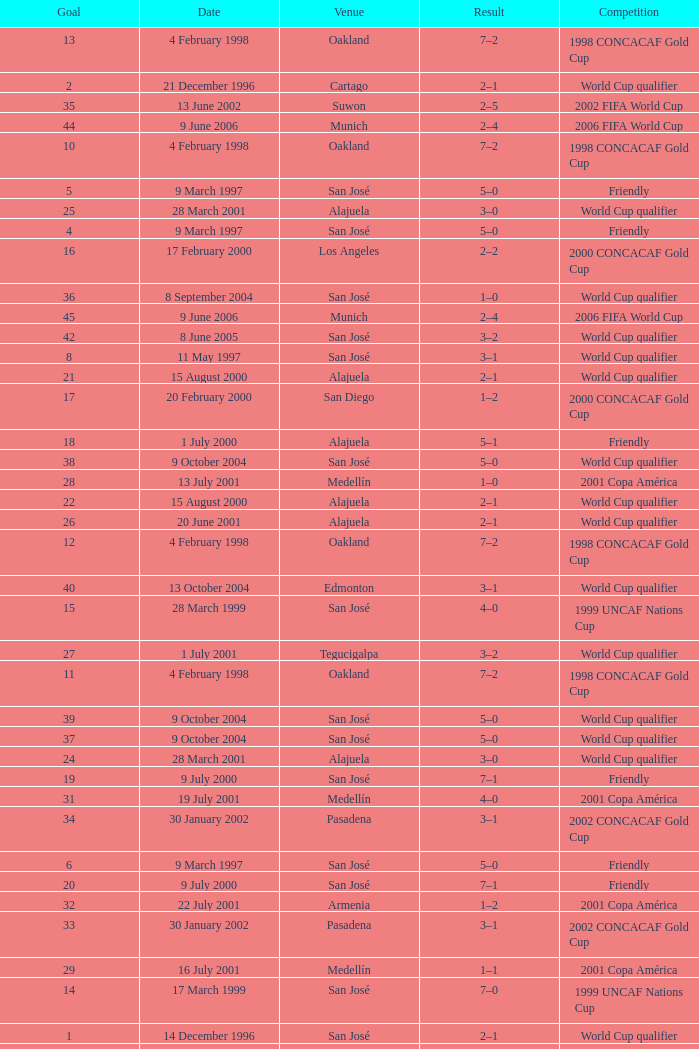What is the result in oakland? 7–2, 7–2, 7–2, 7–2. Could you parse the entire table? {'header': ['Goal', 'Date', 'Venue', 'Result', 'Competition'], 'rows': [['13', '4 February 1998', 'Oakland', '7–2', '1998 CONCACAF Gold Cup'], ['2', '21 December 1996', 'Cartago', '2–1', 'World Cup qualifier'], ['35', '13 June 2002', 'Suwon', '2–5', '2002 FIFA World Cup'], ['44', '9 June 2006', 'Munich', '2–4', '2006 FIFA World Cup'], ['10', '4 February 1998', 'Oakland', '7–2', '1998 CONCACAF Gold Cup'], ['5', '9 March 1997', 'San José', '5–0', 'Friendly'], ['25', '28 March 2001', 'Alajuela', '3–0', 'World Cup qualifier'], ['4', '9 March 1997', 'San José', '5–0', 'Friendly'], ['16', '17 February 2000', 'Los Angeles', '2–2', '2000 CONCACAF Gold Cup'], ['36', '8 September 2004', 'San José', '1–0', 'World Cup qualifier'], ['45', '9 June 2006', 'Munich', '2–4', '2006 FIFA World Cup'], ['42', '8 June 2005', 'San José', '3–2', 'World Cup qualifier'], ['8', '11 May 1997', 'San José', '3–1', 'World Cup qualifier'], ['21', '15 August 2000', 'Alajuela', '2–1', 'World Cup qualifier'], ['17', '20 February 2000', 'San Diego', '1–2', '2000 CONCACAF Gold Cup'], ['18', '1 July 2000', 'Alajuela', '5–1', 'Friendly'], ['38', '9 October 2004', 'San José', '5–0', 'World Cup qualifier'], ['28', '13 July 2001', 'Medellín', '1–0', '2001 Copa América'], ['22', '15 August 2000', 'Alajuela', '2–1', 'World Cup qualifier'], ['26', '20 June 2001', 'Alajuela', '2–1', 'World Cup qualifier'], ['12', '4 February 1998', 'Oakland', '7–2', '1998 CONCACAF Gold Cup'], ['40', '13 October 2004', 'Edmonton', '3–1', 'World Cup qualifier'], ['15', '28 March 1999', 'San José', '4–0', '1999 UNCAF Nations Cup'], ['27', '1 July 2001', 'Tegucigalpa', '3–2', 'World Cup qualifier'], ['11', '4 February 1998', 'Oakland', '7–2', '1998 CONCACAF Gold Cup'], ['39', '9 October 2004', 'San José', '5–0', 'World Cup qualifier'], ['37', '9 October 2004', 'San José', '5–0', 'World Cup qualifier'], ['24', '28 March 2001', 'Alajuela', '3–0', 'World Cup qualifier'], ['19', '9 July 2000', 'San José', '7–1', 'Friendly'], ['31', '19 July 2001', 'Medellín', '4–0', '2001 Copa América'], ['34', '30 January 2002', 'Pasadena', '3–1', '2002 CONCACAF Gold Cup'], ['6', '9 March 1997', 'San José', '5–0', 'Friendly'], ['20', '9 July 2000', 'San José', '7–1', 'Friendly'], ['32', '22 July 2001', 'Armenia', '1–2', '2001 Copa América'], ['33', '30 January 2002', 'Pasadena', '3–1', '2002 CONCACAF Gold Cup'], ['29', '16 July 2001', 'Medellín', '1–1', '2001 Copa América'], ['14', '17 March 1999', 'San José', '7–0', '1999 UNCAF Nations Cup'], ['1', '14 December 1996', 'San José', '2–1', 'World Cup qualifier'], ['30', '19 July 2001', 'Medellín', '4–0', '2001 Copa América'], ['23', '6 January 2001', 'Miami', '5–2', 'World Cup qualifier'], ['43', '8 October 2005', 'San José', '3–0', 'World Cup qualifier'], ['9', '9 November 1997', 'Mexico DF', '3–3', 'World Cup qualifier'], ['3', '21 December 1996', 'Cartago', '2–1', 'World Cup qualifier'], ['41', '9 February 2005', 'San José', '1–2', 'World Cup qualifier'], ['7', '11 May 1997', 'San José', '3–1', 'World Cup qualifier']]} 